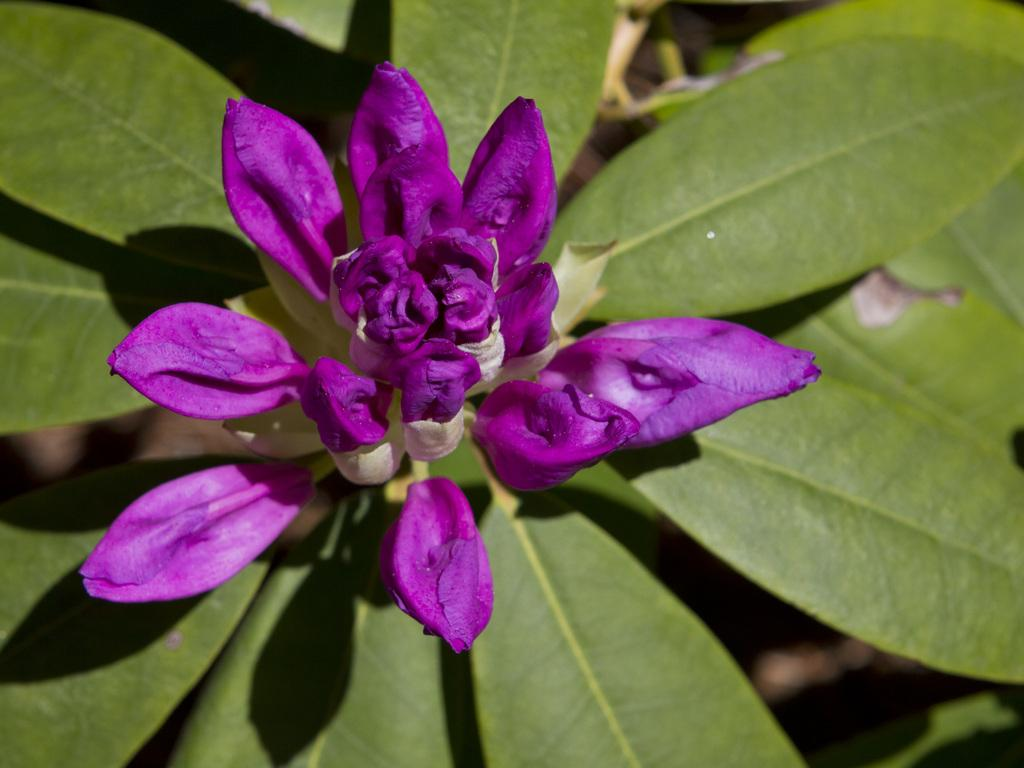What type of plants can be seen in the image? There are flowers in the image. What color are the flowers? The flowers are in violet color. What else can be seen in the image besides the flowers? There are leaves in the image. What color are the leaves? The leaves are in green color. Can you see a hen sitting on the cushion in the image? There is no hen or cushion present in the image. Is there any steam coming out of the flowers in the image? There is no steam present in the image; it features flowers and leaves. 